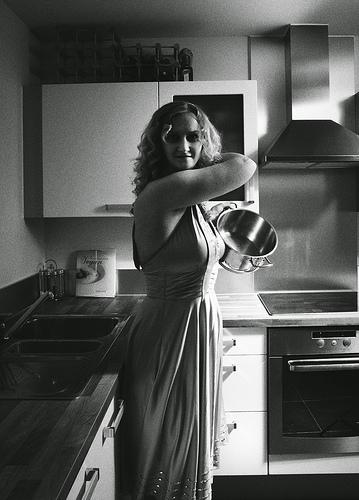Evaluate the image's setting and identify its main focus. The image is set in a kitchen, with the main focus on the woman holding the pot. List three objects near the woman in the kitchen. A stainless steel oven, a vent hood, and a wine rack are near the woman in the kitchen. Provide a basic description of the oven and its immediate surroundings. The oven is silver with a black window, located near a stove with knobs and an empty black stove top. Identify the presence of any spices or flavoring in the image. Various flavoring spices, salt, and pepper can be seen in the image. Can you identify the material used for the counter top and the cabinets? The counter top is made of wood and the cabinets are white. Briefly describe the appearance of the woman's hair. The woman has curly, blonde hair. What is placed at the back of the counter? A cook book is placed at the back of the counter. What is the woman in the image wearing and doing? The woman is wearing a formal dress and holding a stainless steel pot in the kitchen. Mention two objects related to water in the image. A stainless steel sink and a stainless steel faucet can be seen in the image. Analyze the image and describe the primary activity taking place. A woman wearing a dress is holding a metal pot in the kitchen, surrounded by various appliances and objects. Is the woman's hair in a ponytail? The provided captions mention that the woman has curly and blonde hair, but there is no mention of her hairstyle being a ponytail. Is the oven in the image a gas stove? The provided captions mention the oven's color and design but not the type (gas or electric), making this question misleading. Is the pot the woman is holding made of copper? The pot is mentioned as being silver, not copper, making this instruction misleading. Is the woman in the image wearing a blue dress? There is no mention of the color of the dress in the given information, so it's a misleading question. Is there a kettle on the stove top? There is no mention of a kettle in the provided captions, making this question misleading as it refers to an item that isn't described in the image information. Is there a plate with food on the counter? There is no mention of a plate with food in the given information, so asking about it would be misleading. 